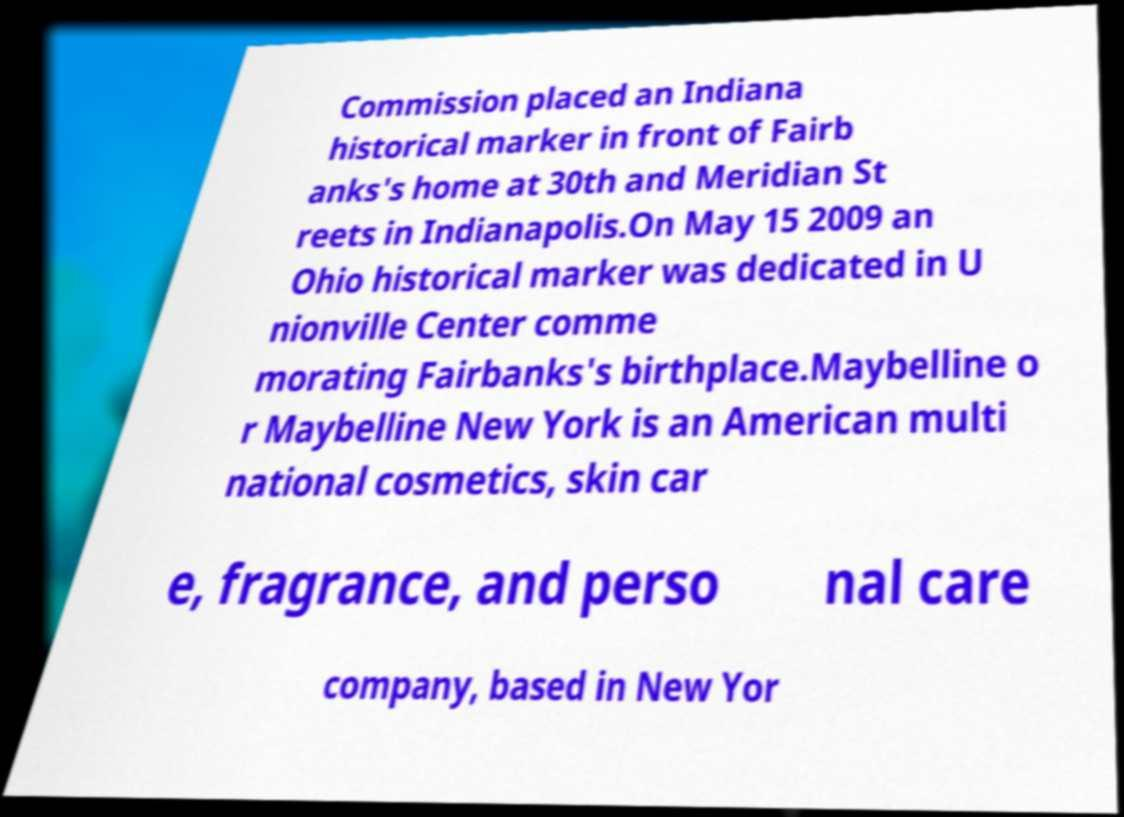For documentation purposes, I need the text within this image transcribed. Could you provide that? Commission placed an Indiana historical marker in front of Fairb anks's home at 30th and Meridian St reets in Indianapolis.On May 15 2009 an Ohio historical marker was dedicated in U nionville Center comme morating Fairbanks's birthplace.Maybelline o r Maybelline New York is an American multi national cosmetics, skin car e, fragrance, and perso nal care company, based in New Yor 